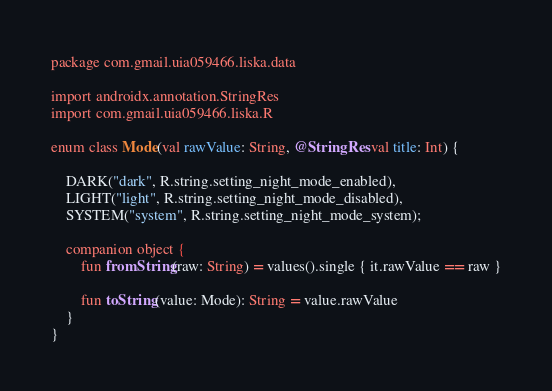Convert code to text. <code><loc_0><loc_0><loc_500><loc_500><_Kotlin_>package com.gmail.uia059466.liska.data

import androidx.annotation.StringRes
import com.gmail.uia059466.liska.R

enum class Mode(val rawValue: String, @StringRes val title: Int) {

    DARK("dark", R.string.setting_night_mode_enabled),
    LIGHT("light", R.string.setting_night_mode_disabled),
    SYSTEM("system", R.string.setting_night_mode_system);

    companion object {
        fun fromString(raw: String) = values().single { it.rawValue == raw }

        fun toString(value: Mode): String = value.rawValue
    }
}</code> 